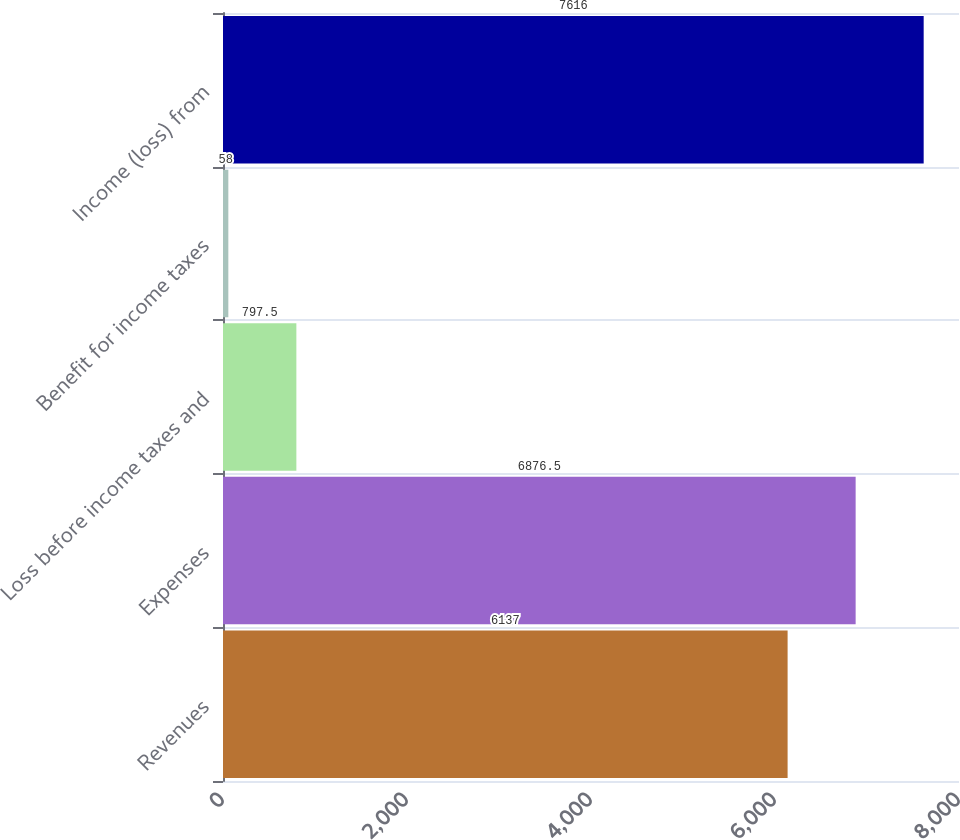<chart> <loc_0><loc_0><loc_500><loc_500><bar_chart><fcel>Revenues<fcel>Expenses<fcel>Loss before income taxes and<fcel>Benefit for income taxes<fcel>Income (loss) from<nl><fcel>6137<fcel>6876.5<fcel>797.5<fcel>58<fcel>7616<nl></chart> 